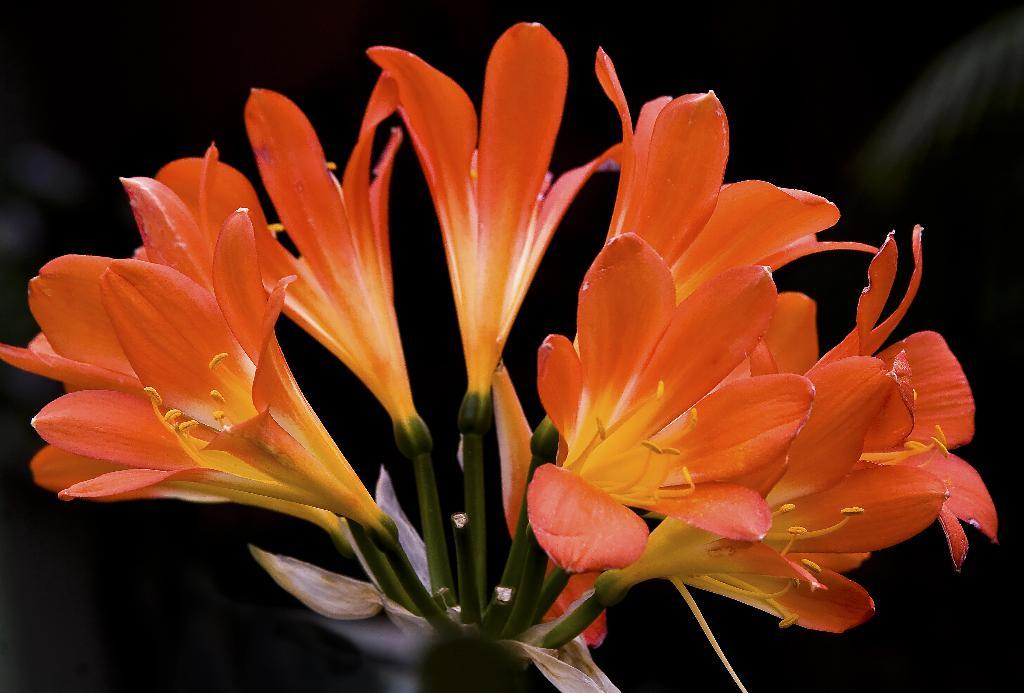What type of living organisms can be seen in the image? There are flowers in the image. What is the color of the background in the image? The background of the image is dark. Can you tell me how many fangs are visible on the flowers in the image? There are no fangs present on the flowers in the image, as flowers do not have fangs. What event might have caused the flowers to grow in the image? The facts provided do not give any information about the cause of the flowers' growth, so it cannot be determined from the image. 